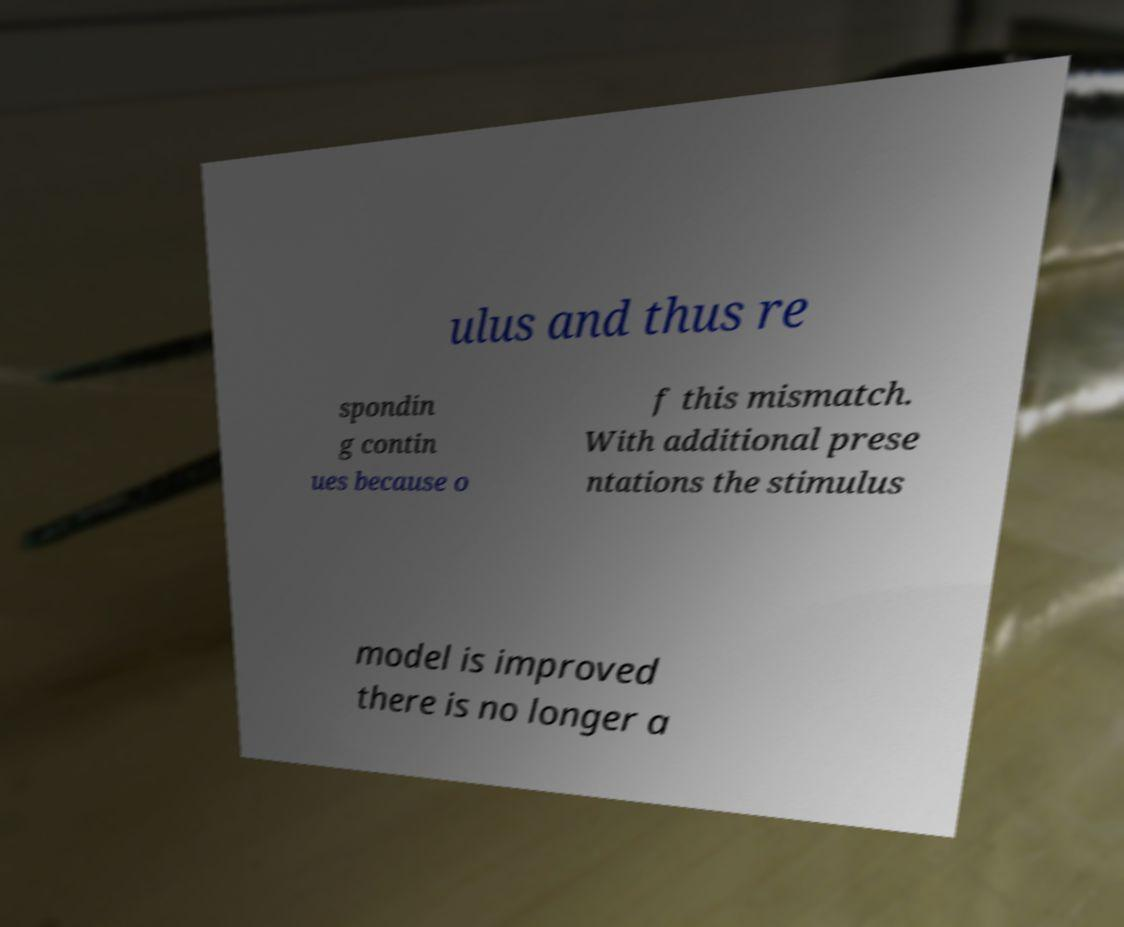I need the written content from this picture converted into text. Can you do that? ulus and thus re spondin g contin ues because o f this mismatch. With additional prese ntations the stimulus model is improved there is no longer a 